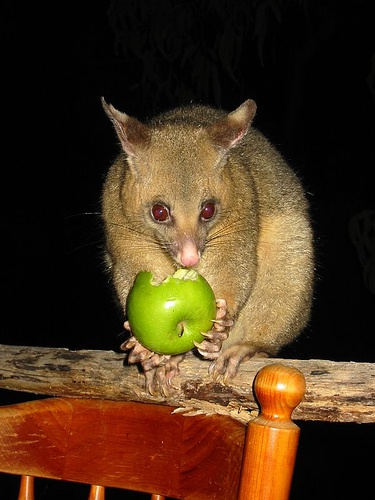Describe the objects in this image and their specific colors. I can see chair in black, maroon, red, and brown tones and apple in black, khaki, olive, and yellow tones in this image. 